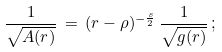<formula> <loc_0><loc_0><loc_500><loc_500>\frac { 1 } { \sqrt { A ( r ) } } \, = \, ( r - \rho ) ^ { - \frac { s } { 2 } } \, \frac { 1 } { \sqrt { g ( r ) } } \, ;</formula> 